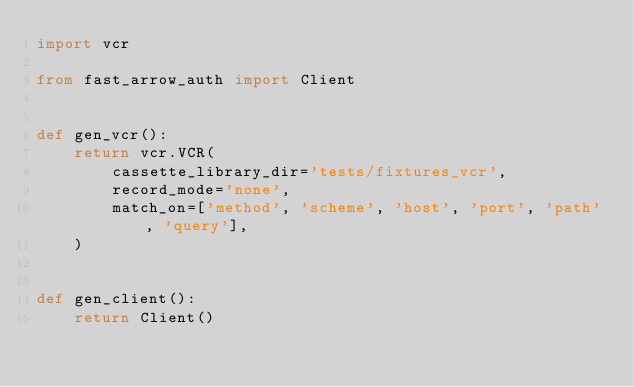<code> <loc_0><loc_0><loc_500><loc_500><_Python_>import vcr

from fast_arrow_auth import Client


def gen_vcr():
    return vcr.VCR(
        cassette_library_dir='tests/fixtures_vcr',
        record_mode='none',
        match_on=['method', 'scheme', 'host', 'port', 'path', 'query'],
    )


def gen_client():
    return Client()
</code> 